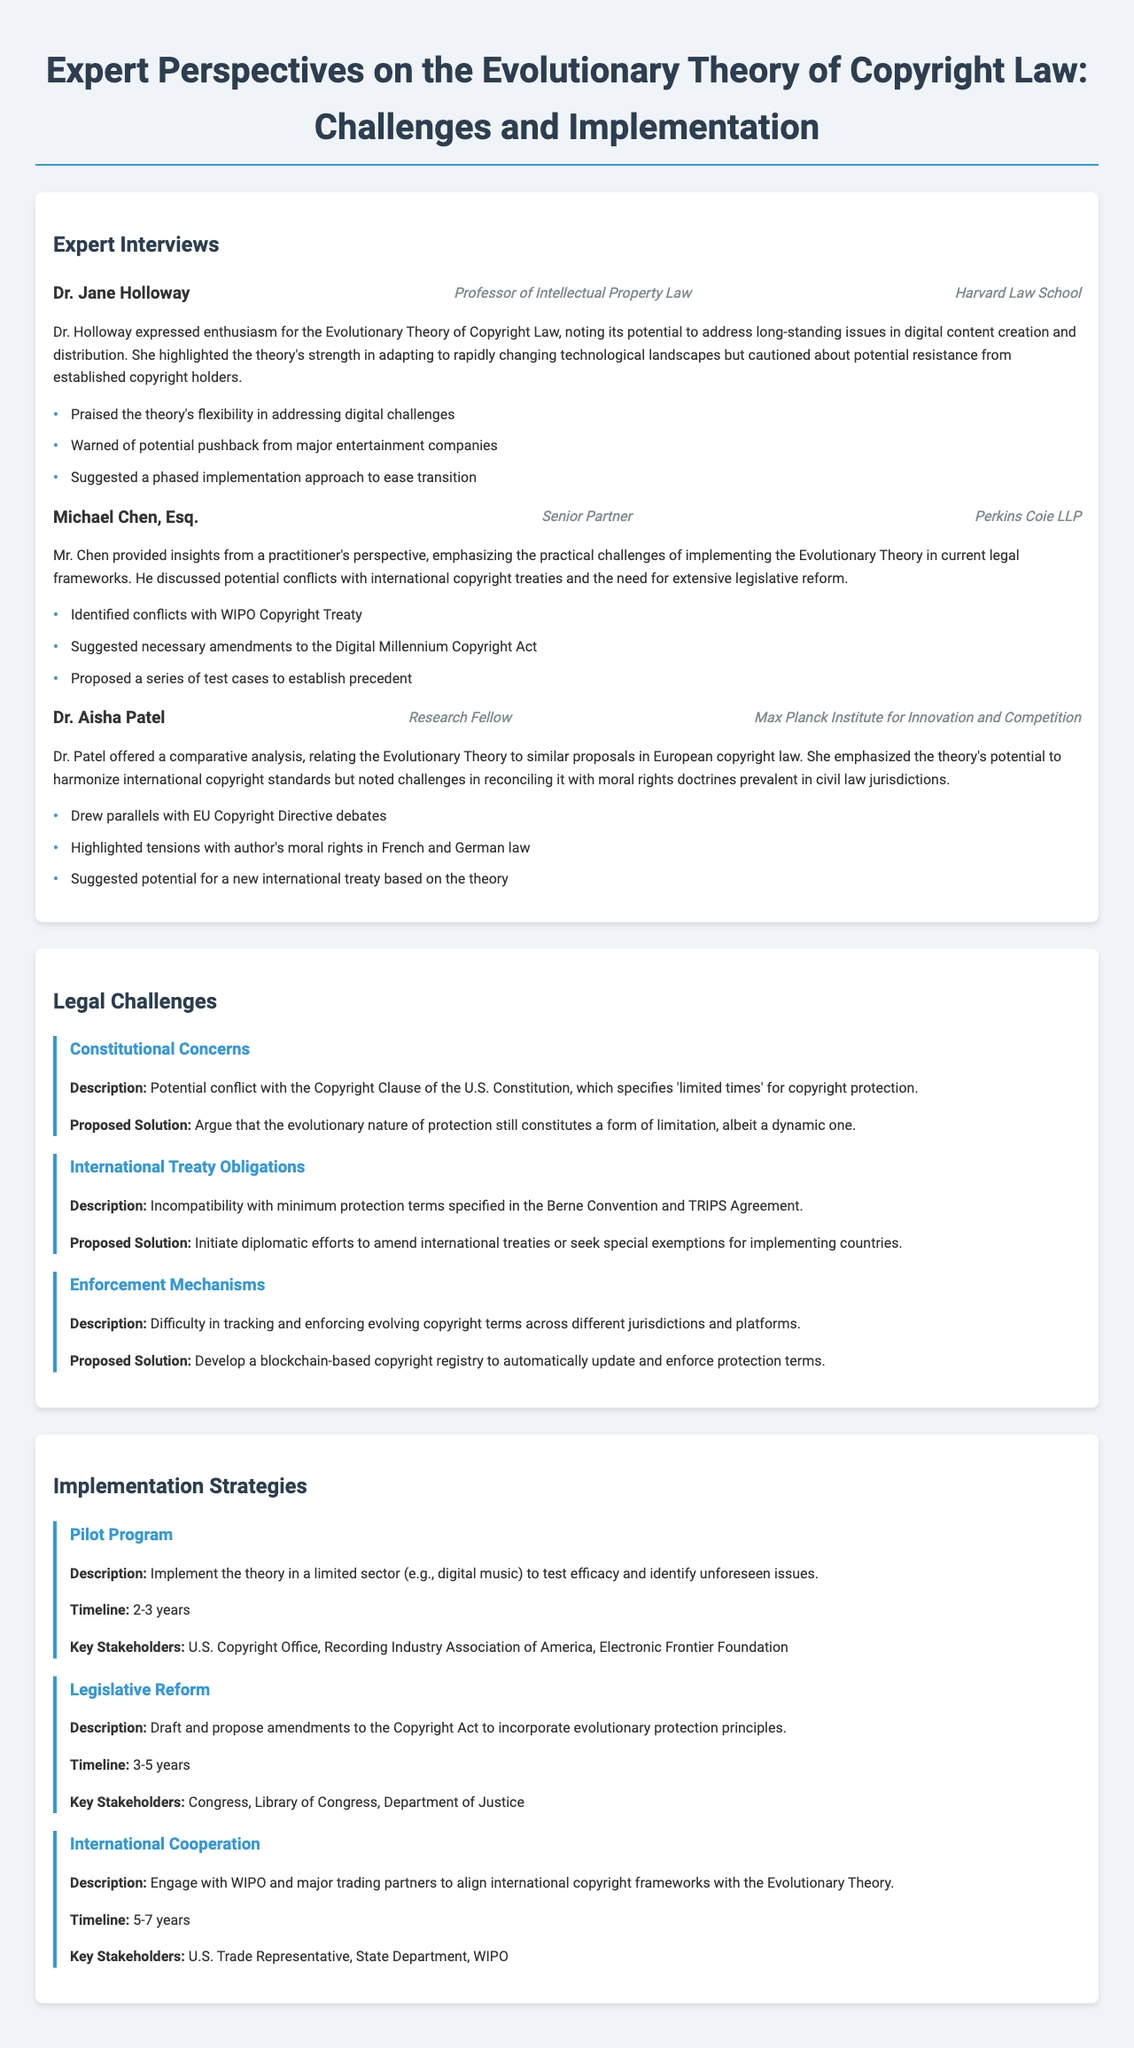What is the title of the report? The title of the report is stated at the beginning of the document.
Answer: Expert Perspectives on the Evolutionary Theory of Copyright Law: Challenges and Implementation Who is the professor of Intellectual Property Law interviewed? The report lists the interviews conducted with various experts, including their titles and institutions.
Answer: Dr. Jane Holloway What university is Dr. Aisha Patel affiliated with? The document includes the institutions where the experts work.
Answer: Max Planck Institute for Innovation and Competition What challenge involves tracking copyright terms across jurisdictions? The legal challenges section describes various issues with the implementation of the theory.
Answer: Enforcement Mechanisms How long is the timeline for the Pilot Program strategy? The timeline for implementing the strategies is provided for each one.
Answer: 2-3 years What solution is proposed for conflicts with international treaty obligations? Each legal challenge has a proposed solution detailed within the document.
Answer: Initiate diplomatic efforts to amend international treaties What type of challenges does Michael Chen, Esq. identify? The document includes insights from experts that outline legal challenges they foresee in implementing the theory.
Answer: Conflicts with WIPO Copyright Treaty Which expert suggested a phased implementation approach? Each interview highlights key points made by the experts regarding the theory and its implementation.
Answer: Dr. Jane Holloway 